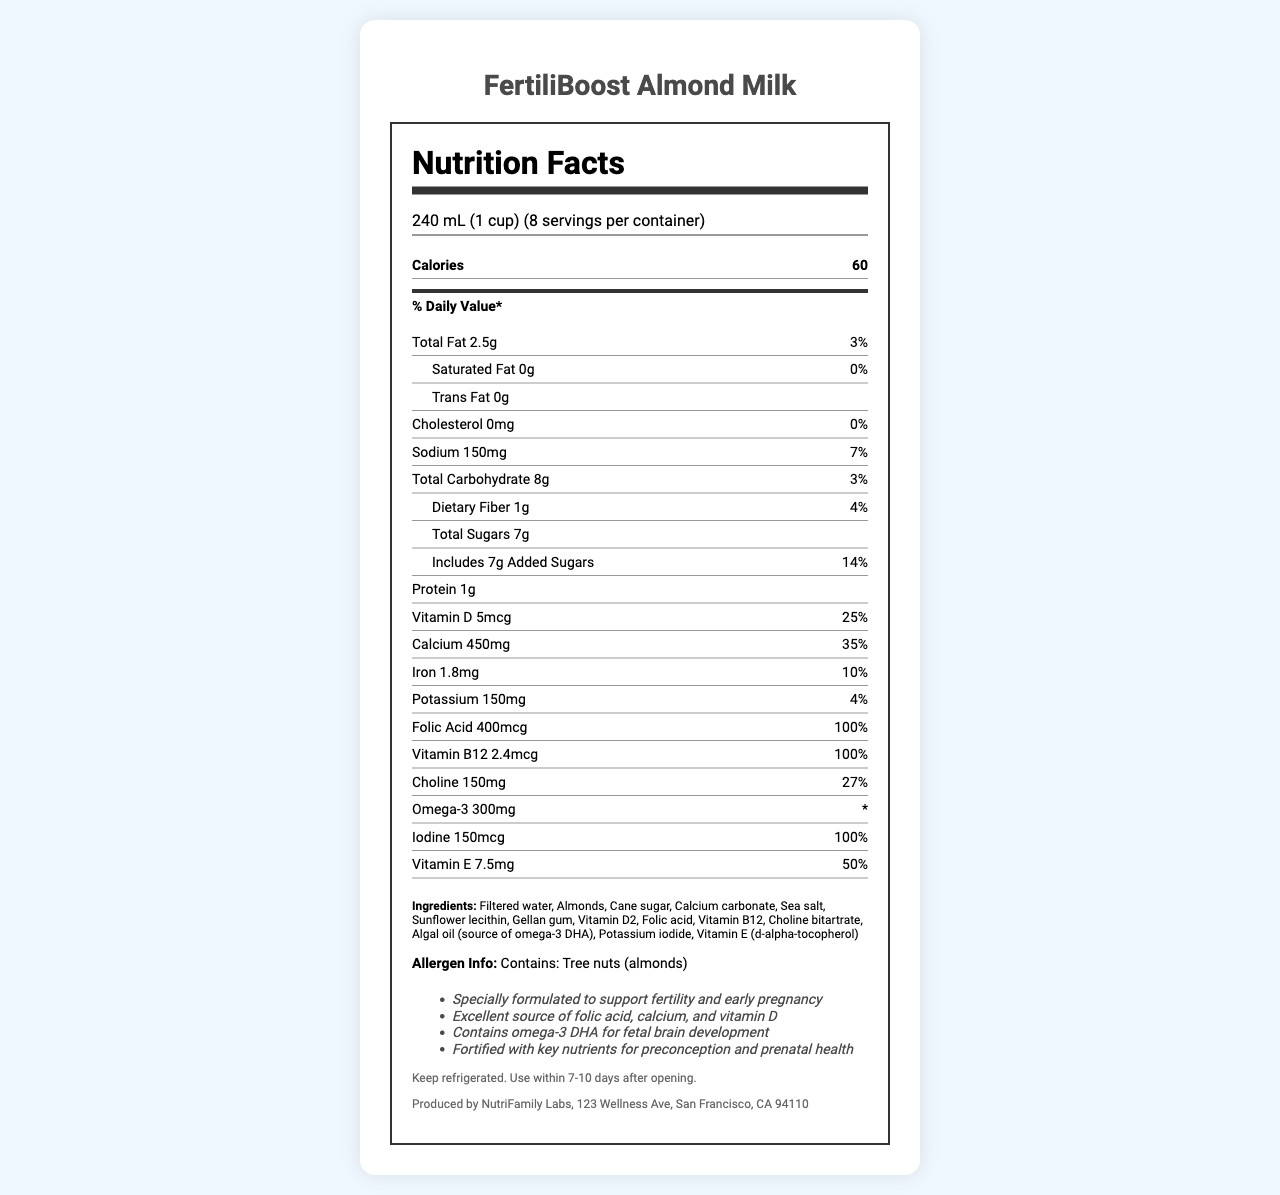what is the serving size? The serving size is clearly mentioned at the top of the Nutrition Facts label: "240 mL (1 cup)".
Answer: 240 mL (1 cup) How many calories are there per serving? The document states that there are 60 calories per serving.
Answer: 60 What is the amount of added sugars per serving? The document lists added sugars as 7g per serving.
Answer: 7g How much calcium does one serving provide? The document specifies that one serving contains 450mg of calcium.
Answer: 450mg What percentage of the Daily Value for vitamin D does one serving provide? The document states that one serving provides 25% of the Daily Value of vitamin D.
Answer: 25% What is the main allergen listed in the allergen information? The allergen info section states that the product contains tree nuts (almonds).
Answer: Tree nuts (almonds) Which nutrient is present in the highest daily value percentage? A. Vitamin D B. Folic Acid C. Calcium D. Vitamin E Folic Acid has a daily value percentage of 100%.
Answer: B. Folic Acid How many servings are there per container? A. 6 B. 8 C. 10 D. 12 The document mentions that there are 8 servings per container.
Answer: B. 8 Is there any cholesterol in this product? The document lists cholesterol amount as 0mg, thereby indicating that there is no cholesterol.
Answer: No Does the product contain any omega-3 fatty acids? The document states that one serving contains 300mg of Omega-3.
Answer: Yes Describe the key claims made by the manufacturer regarding this product. These claims are listed in the "claimStatements" section of the document.
Answer: The product is specially formulated to support fertility and early pregnancy, is an excellent source of folic acid, calcium, and vitamin D, contains omega-3 DHA for fetal brain development, and is fortified with key nutrients for preconception and prenatal health. What are the storage instructions for this product? This information can be found towards the end of the document under the storage instructions.
Answer: Keep refrigerated. Use within 7-10 days after opening. Where is the product manufactured? This detail is provided at the bottom of the document under manufacturerInfo.
Answer: Produced by NutriFamily Labs, 123 Wellness Ave, San Francisco, CA 94110 What are the sources of omega-3 DHA in this product? The ingredient list includes "Algal oil (source of omega-3 DHA)".
Answer: Algal oil What is the daily value percentage of sodium per serving? The document lists the daily value of sodium as 7%.
Answer: 7% What is the % Daily Value of dietary fiber in the product? I. 3% II. 4% III. 7% IV. 14% As mentioned in the document, the daily value percentage for dietary fiber is 4%.
Answer: II. 4% Describe the overall nutritional profile of FertiliBoost Almond Milk. This summary includes essential nutritional details and the health benefits listed in the "claimStatements" section of the document.
Answer: FertiliBoost Almond Milk has 60 calories per serving and is formulated to support fertility and early pregnancy. It includes essential nutrients like calcium (450mg, 35% DV), vitamin D (5mcg, 25% DV), folic acid (400mcg, 100% DV), and omega-3 DHA (300mg). The product is low in total fat (2.5g, 3% DV) and sodium (150mg, 7% DV) and contains no cholesterol or trans fats. It also includes vitamin B12, choline, iodine, and vitamin E, making it a fortified option for preconception and prenatal health. Is there any information on where the almonds are sourced from? The document does not provide any details on the sourcing of the almonds used in the product.
Answer: Not enough information 